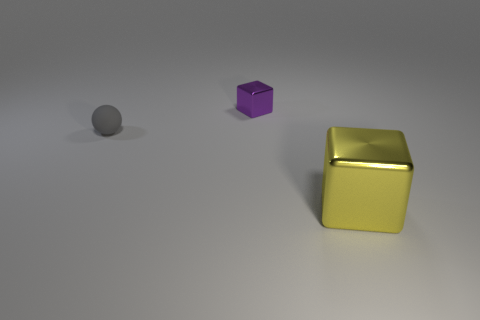How many other things are the same size as the gray rubber sphere?
Your answer should be very brief. 1. What shape is the metallic object right of the shiny cube behind the metal cube in front of the gray sphere?
Keep it short and to the point. Cube. There is a purple cube; is it the same size as the metallic block in front of the small gray matte sphere?
Your response must be concise. No. The object that is both on the left side of the yellow object and to the right of the small gray object is what color?
Ensure brevity in your answer.  Purple. How many other objects are there of the same shape as the large metal thing?
Give a very brief answer. 1. Is the color of the metallic thing that is in front of the tiny matte object the same as the thing behind the matte ball?
Offer a terse response. No. Do the shiny cube behind the small rubber object and the matte ball that is behind the big metallic block have the same size?
Your response must be concise. Yes. Is there anything else that has the same material as the small gray ball?
Provide a short and direct response. No. There is a block behind the shiny cube that is in front of the thing that is behind the rubber ball; what is its material?
Your answer should be very brief. Metal. Does the small metallic object have the same shape as the big yellow metal thing?
Your answer should be very brief. Yes. 